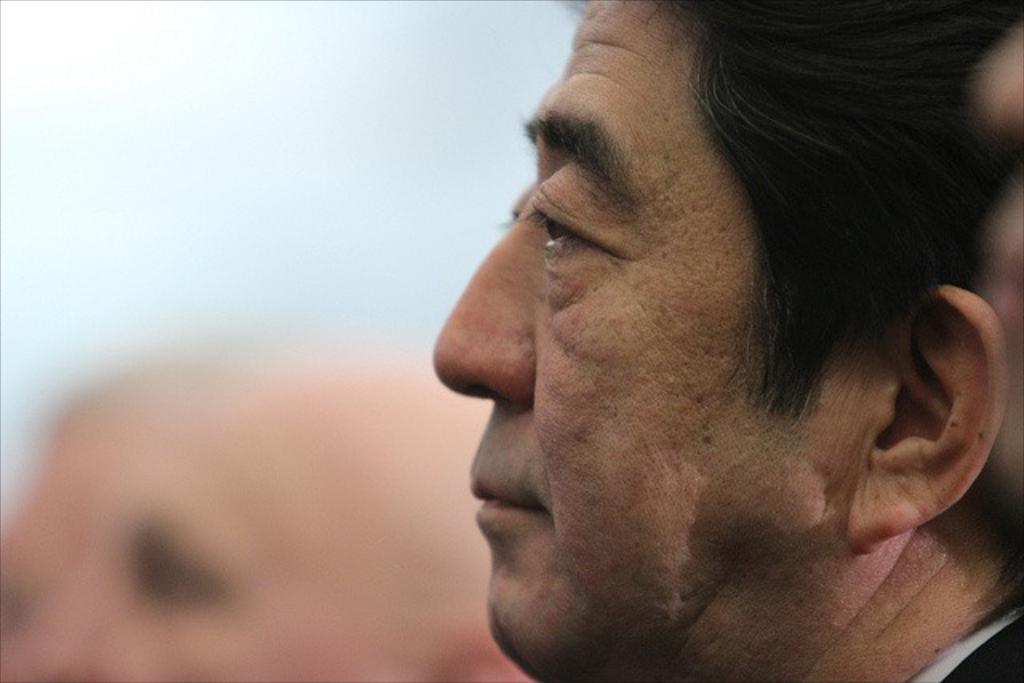What is the main subject of the image? There is a person's face in the image. Can you describe the background of the image? The background of the image is blurry. How many vases are visible in the image? There are no vases present in the image. What type of self-portrait is the person creating in the image? The image does not depict a self-portrait, as it only shows a person's face. 